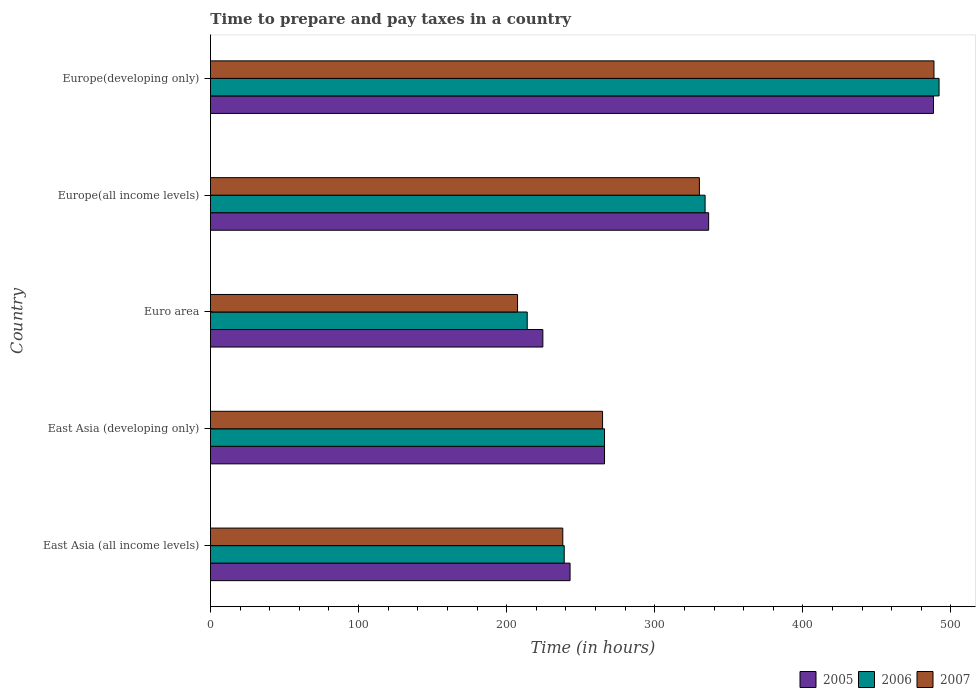How many groups of bars are there?
Offer a terse response. 5. Are the number of bars on each tick of the Y-axis equal?
Make the answer very short. Yes. How many bars are there on the 3rd tick from the top?
Offer a terse response. 3. How many bars are there on the 1st tick from the bottom?
Your answer should be very brief. 3. What is the label of the 1st group of bars from the top?
Keep it short and to the point. Europe(developing only). In how many cases, is the number of bars for a given country not equal to the number of legend labels?
Keep it short and to the point. 0. What is the number of hours required to prepare and pay taxes in 2007 in East Asia (all income levels)?
Keep it short and to the point. 237.9. Across all countries, what is the maximum number of hours required to prepare and pay taxes in 2006?
Give a very brief answer. 491.97. Across all countries, what is the minimum number of hours required to prepare and pay taxes in 2007?
Your response must be concise. 207.35. In which country was the number of hours required to prepare and pay taxes in 2006 maximum?
Provide a succinct answer. Europe(developing only). What is the total number of hours required to prepare and pay taxes in 2007 in the graph?
Ensure brevity in your answer.  1528.68. What is the difference between the number of hours required to prepare and pay taxes in 2007 in Europe(all income levels) and that in Europe(developing only)?
Your answer should be compact. -158.38. What is the difference between the number of hours required to prepare and pay taxes in 2005 in Euro area and the number of hours required to prepare and pay taxes in 2006 in East Asia (developing only)?
Offer a very short reply. -41.65. What is the average number of hours required to prepare and pay taxes in 2006 per country?
Your answer should be compact. 308.96. What is the difference between the number of hours required to prepare and pay taxes in 2007 and number of hours required to prepare and pay taxes in 2005 in Europe(developing only)?
Make the answer very short. 0.32. In how many countries, is the number of hours required to prepare and pay taxes in 2006 greater than 20 hours?
Your response must be concise. 5. What is the ratio of the number of hours required to prepare and pay taxes in 2006 in Euro area to that in Europe(all income levels)?
Give a very brief answer. 0.64. Is the number of hours required to prepare and pay taxes in 2007 in Euro area less than that in Europe(developing only)?
Ensure brevity in your answer.  Yes. What is the difference between the highest and the second highest number of hours required to prepare and pay taxes in 2007?
Your answer should be very brief. 158.38. What is the difference between the highest and the lowest number of hours required to prepare and pay taxes in 2006?
Your response must be concise. 278.09. In how many countries, is the number of hours required to prepare and pay taxes in 2005 greater than the average number of hours required to prepare and pay taxes in 2005 taken over all countries?
Ensure brevity in your answer.  2. What does the 1st bar from the top in Europe(developing only) represents?
Ensure brevity in your answer.  2007. How many bars are there?
Provide a short and direct response. 15. Are all the bars in the graph horizontal?
Offer a terse response. Yes. How many countries are there in the graph?
Your answer should be very brief. 5. What is the difference between two consecutive major ticks on the X-axis?
Give a very brief answer. 100. Are the values on the major ticks of X-axis written in scientific E-notation?
Make the answer very short. No. Where does the legend appear in the graph?
Provide a succinct answer. Bottom right. How are the legend labels stacked?
Offer a terse response. Horizontal. What is the title of the graph?
Your answer should be very brief. Time to prepare and pay taxes in a country. What is the label or title of the X-axis?
Your answer should be very brief. Time (in hours). What is the label or title of the Y-axis?
Your response must be concise. Country. What is the Time (in hours) in 2005 in East Asia (all income levels)?
Offer a terse response. 242.81. What is the Time (in hours) in 2006 in East Asia (all income levels)?
Provide a succinct answer. 238.86. What is the Time (in hours) of 2007 in East Asia (all income levels)?
Give a very brief answer. 237.9. What is the Time (in hours) of 2005 in East Asia (developing only)?
Provide a succinct answer. 266.08. What is the Time (in hours) in 2006 in East Asia (developing only)?
Your response must be concise. 266.08. What is the Time (in hours) of 2007 in East Asia (developing only)?
Ensure brevity in your answer.  264.75. What is the Time (in hours) in 2005 in Euro area?
Ensure brevity in your answer.  224.44. What is the Time (in hours) of 2006 in Euro area?
Provide a succinct answer. 213.88. What is the Time (in hours) of 2007 in Euro area?
Provide a short and direct response. 207.35. What is the Time (in hours) in 2005 in Europe(all income levels)?
Provide a succinct answer. 336.38. What is the Time (in hours) of 2006 in Europe(all income levels)?
Make the answer very short. 333.99. What is the Time (in hours) of 2007 in Europe(all income levels)?
Make the answer very short. 330.14. What is the Time (in hours) in 2005 in Europe(developing only)?
Keep it short and to the point. 488.21. What is the Time (in hours) in 2006 in Europe(developing only)?
Give a very brief answer. 491.97. What is the Time (in hours) of 2007 in Europe(developing only)?
Provide a succinct answer. 488.53. Across all countries, what is the maximum Time (in hours) of 2005?
Your response must be concise. 488.21. Across all countries, what is the maximum Time (in hours) in 2006?
Offer a very short reply. 491.97. Across all countries, what is the maximum Time (in hours) of 2007?
Your answer should be compact. 488.53. Across all countries, what is the minimum Time (in hours) of 2005?
Offer a very short reply. 224.44. Across all countries, what is the minimum Time (in hours) in 2006?
Provide a succinct answer. 213.88. Across all countries, what is the minimum Time (in hours) of 2007?
Keep it short and to the point. 207.35. What is the total Time (in hours) of 2005 in the graph?
Your response must be concise. 1557.92. What is the total Time (in hours) in 2006 in the graph?
Give a very brief answer. 1544.79. What is the total Time (in hours) of 2007 in the graph?
Provide a short and direct response. 1528.68. What is the difference between the Time (in hours) of 2005 in East Asia (all income levels) and that in East Asia (developing only)?
Ensure brevity in your answer.  -23.27. What is the difference between the Time (in hours) of 2006 in East Asia (all income levels) and that in East Asia (developing only)?
Ensure brevity in your answer.  -27.22. What is the difference between the Time (in hours) in 2007 in East Asia (all income levels) and that in East Asia (developing only)?
Offer a terse response. -26.85. What is the difference between the Time (in hours) in 2005 in East Asia (all income levels) and that in Euro area?
Provide a short and direct response. 18.38. What is the difference between the Time (in hours) in 2006 in East Asia (all income levels) and that in Euro area?
Your response must be concise. 24.98. What is the difference between the Time (in hours) in 2007 in East Asia (all income levels) and that in Euro area?
Make the answer very short. 30.55. What is the difference between the Time (in hours) in 2005 in East Asia (all income levels) and that in Europe(all income levels)?
Keep it short and to the point. -93.57. What is the difference between the Time (in hours) of 2006 in East Asia (all income levels) and that in Europe(all income levels)?
Your answer should be compact. -95.13. What is the difference between the Time (in hours) in 2007 in East Asia (all income levels) and that in Europe(all income levels)?
Give a very brief answer. -92.24. What is the difference between the Time (in hours) of 2005 in East Asia (all income levels) and that in Europe(developing only)?
Your answer should be compact. -245.39. What is the difference between the Time (in hours) in 2006 in East Asia (all income levels) and that in Europe(developing only)?
Keep it short and to the point. -253.11. What is the difference between the Time (in hours) in 2007 in East Asia (all income levels) and that in Europe(developing only)?
Offer a terse response. -250.63. What is the difference between the Time (in hours) of 2005 in East Asia (developing only) and that in Euro area?
Make the answer very short. 41.65. What is the difference between the Time (in hours) of 2006 in East Asia (developing only) and that in Euro area?
Give a very brief answer. 52.2. What is the difference between the Time (in hours) in 2007 in East Asia (developing only) and that in Euro area?
Keep it short and to the point. 57.4. What is the difference between the Time (in hours) in 2005 in East Asia (developing only) and that in Europe(all income levels)?
Provide a short and direct response. -70.3. What is the difference between the Time (in hours) of 2006 in East Asia (developing only) and that in Europe(all income levels)?
Offer a very short reply. -67.91. What is the difference between the Time (in hours) in 2007 in East Asia (developing only) and that in Europe(all income levels)?
Offer a very short reply. -65.39. What is the difference between the Time (in hours) of 2005 in East Asia (developing only) and that in Europe(developing only)?
Your response must be concise. -222.12. What is the difference between the Time (in hours) of 2006 in East Asia (developing only) and that in Europe(developing only)?
Offer a terse response. -225.89. What is the difference between the Time (in hours) of 2007 in East Asia (developing only) and that in Europe(developing only)?
Ensure brevity in your answer.  -223.78. What is the difference between the Time (in hours) of 2005 in Euro area and that in Europe(all income levels)?
Offer a very short reply. -111.95. What is the difference between the Time (in hours) in 2006 in Euro area and that in Europe(all income levels)?
Provide a succinct answer. -120.11. What is the difference between the Time (in hours) in 2007 in Euro area and that in Europe(all income levels)?
Offer a very short reply. -122.79. What is the difference between the Time (in hours) of 2005 in Euro area and that in Europe(developing only)?
Make the answer very short. -263.77. What is the difference between the Time (in hours) in 2006 in Euro area and that in Europe(developing only)?
Give a very brief answer. -278.09. What is the difference between the Time (in hours) in 2007 in Euro area and that in Europe(developing only)?
Give a very brief answer. -281.17. What is the difference between the Time (in hours) of 2005 in Europe(all income levels) and that in Europe(developing only)?
Offer a very short reply. -151.82. What is the difference between the Time (in hours) of 2006 in Europe(all income levels) and that in Europe(developing only)?
Your response must be concise. -157.98. What is the difference between the Time (in hours) in 2007 in Europe(all income levels) and that in Europe(developing only)?
Your answer should be very brief. -158.38. What is the difference between the Time (in hours) in 2005 in East Asia (all income levels) and the Time (in hours) in 2006 in East Asia (developing only)?
Your response must be concise. -23.27. What is the difference between the Time (in hours) in 2005 in East Asia (all income levels) and the Time (in hours) in 2007 in East Asia (developing only)?
Give a very brief answer. -21.94. What is the difference between the Time (in hours) of 2006 in East Asia (all income levels) and the Time (in hours) of 2007 in East Asia (developing only)?
Make the answer very short. -25.89. What is the difference between the Time (in hours) in 2005 in East Asia (all income levels) and the Time (in hours) in 2006 in Euro area?
Keep it short and to the point. 28.93. What is the difference between the Time (in hours) in 2005 in East Asia (all income levels) and the Time (in hours) in 2007 in Euro area?
Keep it short and to the point. 35.46. What is the difference between the Time (in hours) of 2006 in East Asia (all income levels) and the Time (in hours) of 2007 in Euro area?
Offer a terse response. 31.51. What is the difference between the Time (in hours) in 2005 in East Asia (all income levels) and the Time (in hours) in 2006 in Europe(all income levels)?
Ensure brevity in your answer.  -91.18. What is the difference between the Time (in hours) of 2005 in East Asia (all income levels) and the Time (in hours) of 2007 in Europe(all income levels)?
Your answer should be very brief. -87.33. What is the difference between the Time (in hours) of 2006 in East Asia (all income levels) and the Time (in hours) of 2007 in Europe(all income levels)?
Your response must be concise. -91.28. What is the difference between the Time (in hours) of 2005 in East Asia (all income levels) and the Time (in hours) of 2006 in Europe(developing only)?
Make the answer very short. -249.16. What is the difference between the Time (in hours) of 2005 in East Asia (all income levels) and the Time (in hours) of 2007 in Europe(developing only)?
Offer a very short reply. -245.72. What is the difference between the Time (in hours) of 2006 in East Asia (all income levels) and the Time (in hours) of 2007 in Europe(developing only)?
Provide a short and direct response. -249.67. What is the difference between the Time (in hours) in 2005 in East Asia (developing only) and the Time (in hours) in 2006 in Euro area?
Give a very brief answer. 52.2. What is the difference between the Time (in hours) of 2005 in East Asia (developing only) and the Time (in hours) of 2007 in Euro area?
Provide a succinct answer. 58.73. What is the difference between the Time (in hours) of 2006 in East Asia (developing only) and the Time (in hours) of 2007 in Euro area?
Your answer should be compact. 58.73. What is the difference between the Time (in hours) of 2005 in East Asia (developing only) and the Time (in hours) of 2006 in Europe(all income levels)?
Offer a terse response. -67.91. What is the difference between the Time (in hours) of 2005 in East Asia (developing only) and the Time (in hours) of 2007 in Europe(all income levels)?
Your answer should be compact. -64.06. What is the difference between the Time (in hours) in 2006 in East Asia (developing only) and the Time (in hours) in 2007 in Europe(all income levels)?
Your answer should be very brief. -64.06. What is the difference between the Time (in hours) in 2005 in East Asia (developing only) and the Time (in hours) in 2006 in Europe(developing only)?
Provide a short and direct response. -225.89. What is the difference between the Time (in hours) of 2005 in East Asia (developing only) and the Time (in hours) of 2007 in Europe(developing only)?
Make the answer very short. -222.44. What is the difference between the Time (in hours) of 2006 in East Asia (developing only) and the Time (in hours) of 2007 in Europe(developing only)?
Your answer should be very brief. -222.44. What is the difference between the Time (in hours) in 2005 in Euro area and the Time (in hours) in 2006 in Europe(all income levels)?
Keep it short and to the point. -109.55. What is the difference between the Time (in hours) of 2005 in Euro area and the Time (in hours) of 2007 in Europe(all income levels)?
Provide a succinct answer. -105.71. What is the difference between the Time (in hours) in 2006 in Euro area and the Time (in hours) in 2007 in Europe(all income levels)?
Provide a short and direct response. -116.26. What is the difference between the Time (in hours) of 2005 in Euro area and the Time (in hours) of 2006 in Europe(developing only)?
Your answer should be compact. -267.53. What is the difference between the Time (in hours) of 2005 in Euro area and the Time (in hours) of 2007 in Europe(developing only)?
Offer a very short reply. -264.09. What is the difference between the Time (in hours) of 2006 in Euro area and the Time (in hours) of 2007 in Europe(developing only)?
Your response must be concise. -274.65. What is the difference between the Time (in hours) in 2005 in Europe(all income levels) and the Time (in hours) in 2006 in Europe(developing only)?
Give a very brief answer. -155.59. What is the difference between the Time (in hours) of 2005 in Europe(all income levels) and the Time (in hours) of 2007 in Europe(developing only)?
Provide a succinct answer. -152.14. What is the difference between the Time (in hours) in 2006 in Europe(all income levels) and the Time (in hours) in 2007 in Europe(developing only)?
Your answer should be compact. -154.54. What is the average Time (in hours) of 2005 per country?
Your answer should be very brief. 311.58. What is the average Time (in hours) of 2006 per country?
Offer a terse response. 308.96. What is the average Time (in hours) in 2007 per country?
Provide a short and direct response. 305.74. What is the difference between the Time (in hours) in 2005 and Time (in hours) in 2006 in East Asia (all income levels)?
Your response must be concise. 3.95. What is the difference between the Time (in hours) of 2005 and Time (in hours) of 2007 in East Asia (all income levels)?
Your response must be concise. 4.91. What is the difference between the Time (in hours) in 2006 and Time (in hours) in 2007 in East Asia (all income levels)?
Offer a very short reply. 0.96. What is the difference between the Time (in hours) of 2005 and Time (in hours) of 2006 in East Asia (developing only)?
Your answer should be compact. 0. What is the difference between the Time (in hours) of 2006 and Time (in hours) of 2007 in East Asia (developing only)?
Your answer should be compact. 1.33. What is the difference between the Time (in hours) in 2005 and Time (in hours) in 2006 in Euro area?
Offer a very short reply. 10.56. What is the difference between the Time (in hours) of 2005 and Time (in hours) of 2007 in Euro area?
Your answer should be compact. 17.08. What is the difference between the Time (in hours) in 2006 and Time (in hours) in 2007 in Euro area?
Ensure brevity in your answer.  6.53. What is the difference between the Time (in hours) in 2005 and Time (in hours) in 2006 in Europe(all income levels)?
Offer a very short reply. 2.39. What is the difference between the Time (in hours) of 2005 and Time (in hours) of 2007 in Europe(all income levels)?
Give a very brief answer. 6.24. What is the difference between the Time (in hours) of 2006 and Time (in hours) of 2007 in Europe(all income levels)?
Provide a succinct answer. 3.84. What is the difference between the Time (in hours) in 2005 and Time (in hours) in 2006 in Europe(developing only)?
Provide a succinct answer. -3.77. What is the difference between the Time (in hours) of 2005 and Time (in hours) of 2007 in Europe(developing only)?
Offer a terse response. -0.32. What is the difference between the Time (in hours) of 2006 and Time (in hours) of 2007 in Europe(developing only)?
Offer a terse response. 3.44. What is the ratio of the Time (in hours) of 2005 in East Asia (all income levels) to that in East Asia (developing only)?
Your answer should be very brief. 0.91. What is the ratio of the Time (in hours) of 2006 in East Asia (all income levels) to that in East Asia (developing only)?
Offer a very short reply. 0.9. What is the ratio of the Time (in hours) in 2007 in East Asia (all income levels) to that in East Asia (developing only)?
Offer a very short reply. 0.9. What is the ratio of the Time (in hours) of 2005 in East Asia (all income levels) to that in Euro area?
Your answer should be compact. 1.08. What is the ratio of the Time (in hours) in 2006 in East Asia (all income levels) to that in Euro area?
Ensure brevity in your answer.  1.12. What is the ratio of the Time (in hours) in 2007 in East Asia (all income levels) to that in Euro area?
Your answer should be very brief. 1.15. What is the ratio of the Time (in hours) in 2005 in East Asia (all income levels) to that in Europe(all income levels)?
Your answer should be compact. 0.72. What is the ratio of the Time (in hours) of 2006 in East Asia (all income levels) to that in Europe(all income levels)?
Your answer should be compact. 0.72. What is the ratio of the Time (in hours) of 2007 in East Asia (all income levels) to that in Europe(all income levels)?
Give a very brief answer. 0.72. What is the ratio of the Time (in hours) in 2005 in East Asia (all income levels) to that in Europe(developing only)?
Your answer should be very brief. 0.5. What is the ratio of the Time (in hours) in 2006 in East Asia (all income levels) to that in Europe(developing only)?
Ensure brevity in your answer.  0.49. What is the ratio of the Time (in hours) in 2007 in East Asia (all income levels) to that in Europe(developing only)?
Ensure brevity in your answer.  0.49. What is the ratio of the Time (in hours) in 2005 in East Asia (developing only) to that in Euro area?
Offer a terse response. 1.19. What is the ratio of the Time (in hours) in 2006 in East Asia (developing only) to that in Euro area?
Your response must be concise. 1.24. What is the ratio of the Time (in hours) in 2007 in East Asia (developing only) to that in Euro area?
Give a very brief answer. 1.28. What is the ratio of the Time (in hours) in 2005 in East Asia (developing only) to that in Europe(all income levels)?
Keep it short and to the point. 0.79. What is the ratio of the Time (in hours) of 2006 in East Asia (developing only) to that in Europe(all income levels)?
Keep it short and to the point. 0.8. What is the ratio of the Time (in hours) of 2007 in East Asia (developing only) to that in Europe(all income levels)?
Offer a terse response. 0.8. What is the ratio of the Time (in hours) of 2005 in East Asia (developing only) to that in Europe(developing only)?
Your response must be concise. 0.55. What is the ratio of the Time (in hours) in 2006 in East Asia (developing only) to that in Europe(developing only)?
Your answer should be compact. 0.54. What is the ratio of the Time (in hours) in 2007 in East Asia (developing only) to that in Europe(developing only)?
Provide a short and direct response. 0.54. What is the ratio of the Time (in hours) of 2005 in Euro area to that in Europe(all income levels)?
Your answer should be compact. 0.67. What is the ratio of the Time (in hours) in 2006 in Euro area to that in Europe(all income levels)?
Make the answer very short. 0.64. What is the ratio of the Time (in hours) in 2007 in Euro area to that in Europe(all income levels)?
Give a very brief answer. 0.63. What is the ratio of the Time (in hours) in 2005 in Euro area to that in Europe(developing only)?
Offer a terse response. 0.46. What is the ratio of the Time (in hours) in 2006 in Euro area to that in Europe(developing only)?
Make the answer very short. 0.43. What is the ratio of the Time (in hours) of 2007 in Euro area to that in Europe(developing only)?
Give a very brief answer. 0.42. What is the ratio of the Time (in hours) in 2005 in Europe(all income levels) to that in Europe(developing only)?
Make the answer very short. 0.69. What is the ratio of the Time (in hours) in 2006 in Europe(all income levels) to that in Europe(developing only)?
Your answer should be very brief. 0.68. What is the ratio of the Time (in hours) of 2007 in Europe(all income levels) to that in Europe(developing only)?
Keep it short and to the point. 0.68. What is the difference between the highest and the second highest Time (in hours) of 2005?
Your response must be concise. 151.82. What is the difference between the highest and the second highest Time (in hours) in 2006?
Provide a short and direct response. 157.98. What is the difference between the highest and the second highest Time (in hours) in 2007?
Offer a terse response. 158.38. What is the difference between the highest and the lowest Time (in hours) of 2005?
Ensure brevity in your answer.  263.77. What is the difference between the highest and the lowest Time (in hours) in 2006?
Ensure brevity in your answer.  278.09. What is the difference between the highest and the lowest Time (in hours) of 2007?
Offer a terse response. 281.17. 